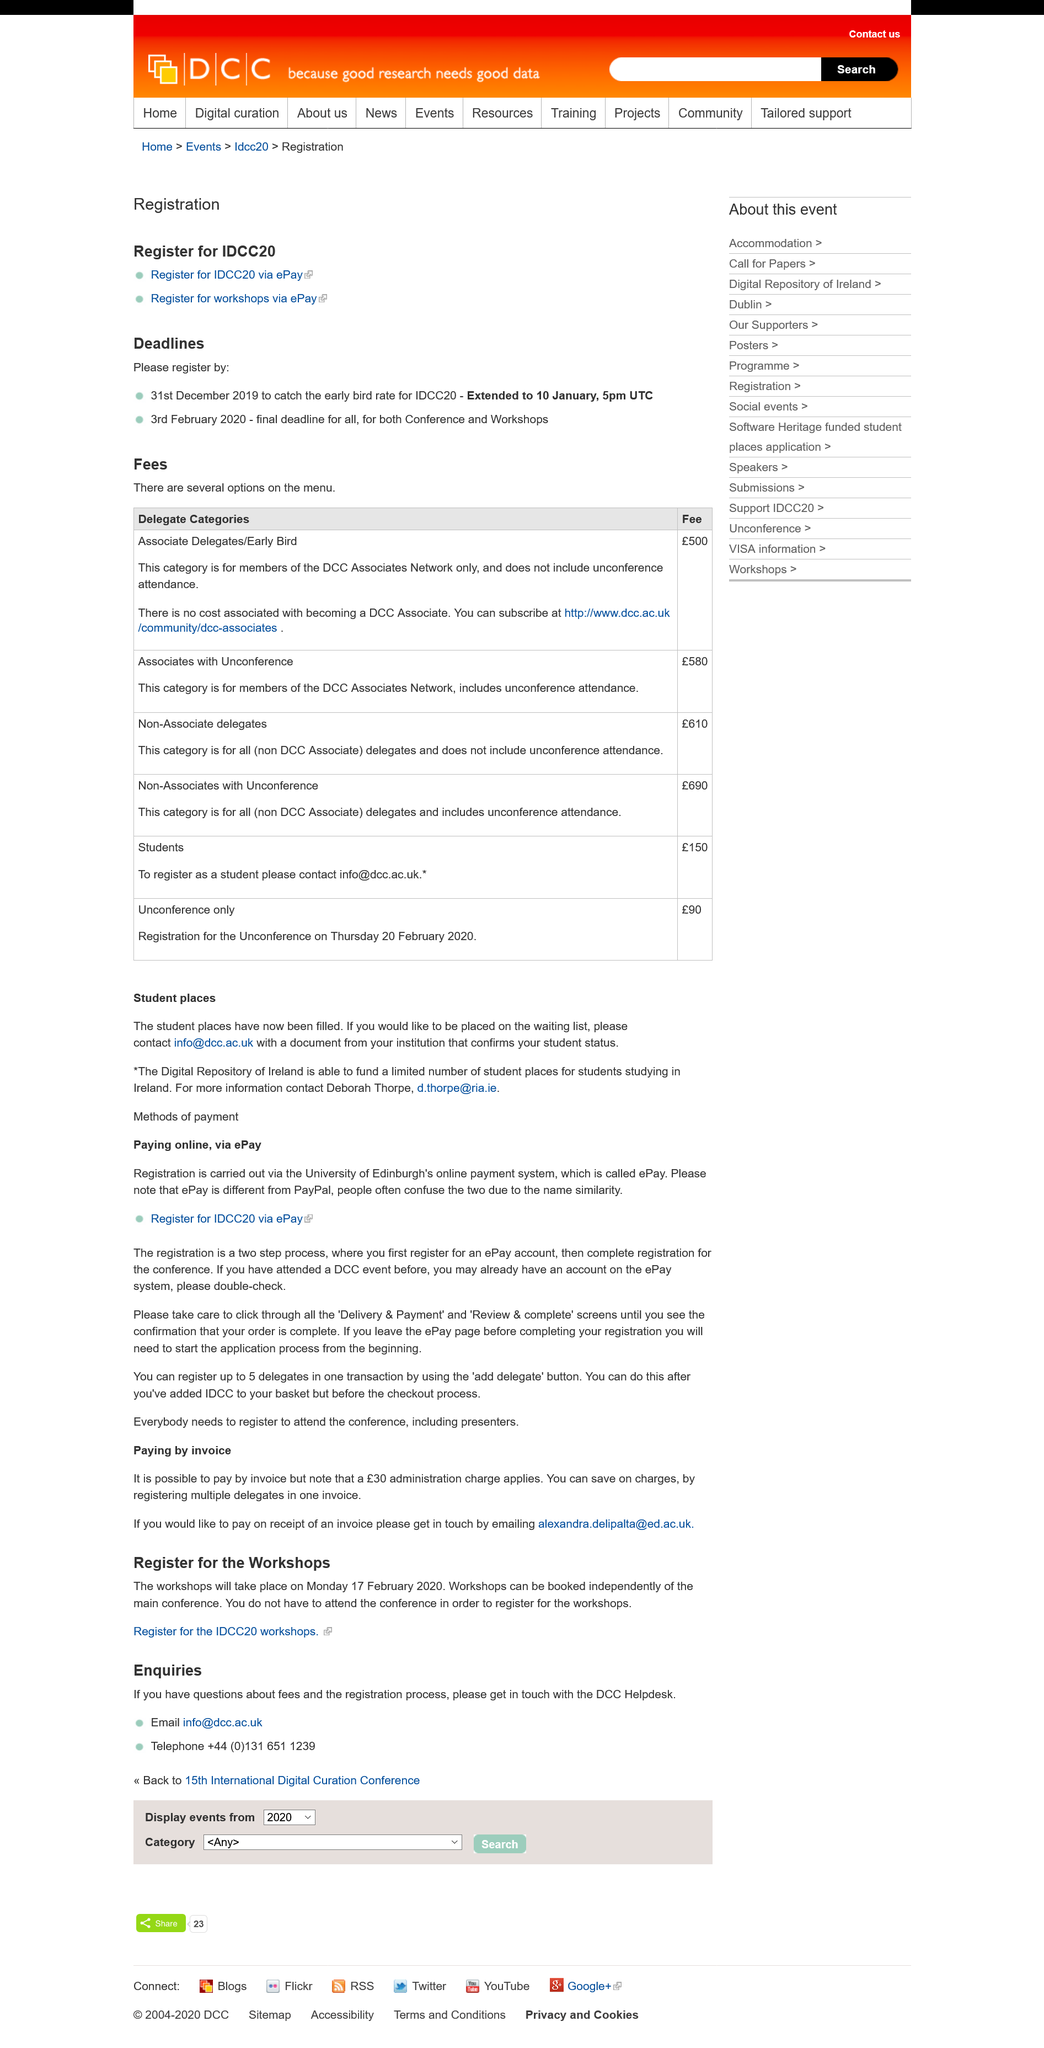Indicate a few pertinent items in this graphic. Payment for registration can be made online through the University of Edinburgh's ePay system during the application process. The entity responsible for contacting in order to be placed on a waiting list is specified as "Contact info@dcc.ac.uk. To obtain additional information regarding studying in Ireland, please contact Deborah Thorpe at [d.thorpe@ria.ie](mailto:d.thorpe@ria.ie). 